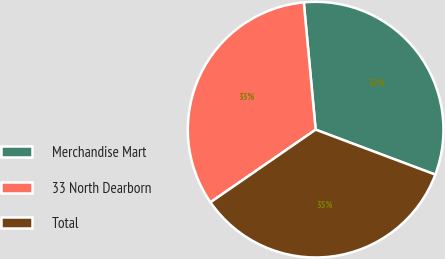<chart> <loc_0><loc_0><loc_500><loc_500><pie_chart><fcel>Merchandise Mart<fcel>33 North Dearborn<fcel>Total<nl><fcel>32.2%<fcel>33.14%<fcel>34.66%<nl></chart> 